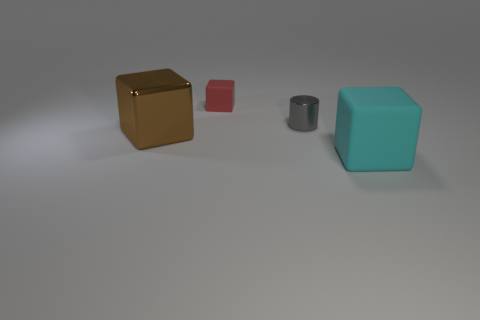Subtract all big cubes. How many cubes are left? 1 Subtract all red cubes. How many cubes are left? 2 Add 4 tiny red matte blocks. How many objects exist? 8 Subtract 2 blocks. How many blocks are left? 1 Subtract all brown cylinders. How many brown blocks are left? 1 Subtract all red cubes. Subtract all small shiny cylinders. How many objects are left? 2 Add 4 large cyan blocks. How many large cyan blocks are left? 5 Add 2 brown cubes. How many brown cubes exist? 3 Subtract 0 gray spheres. How many objects are left? 4 Subtract all cubes. How many objects are left? 1 